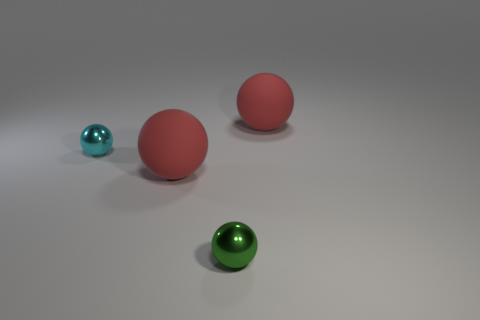Add 2 tiny green metallic balls. How many objects exist? 6 Subtract 0 cyan blocks. How many objects are left? 4 Subtract all green shiny balls. Subtract all large red spheres. How many objects are left? 1 Add 3 cyan things. How many cyan things are left? 4 Add 1 rubber balls. How many rubber balls exist? 3 